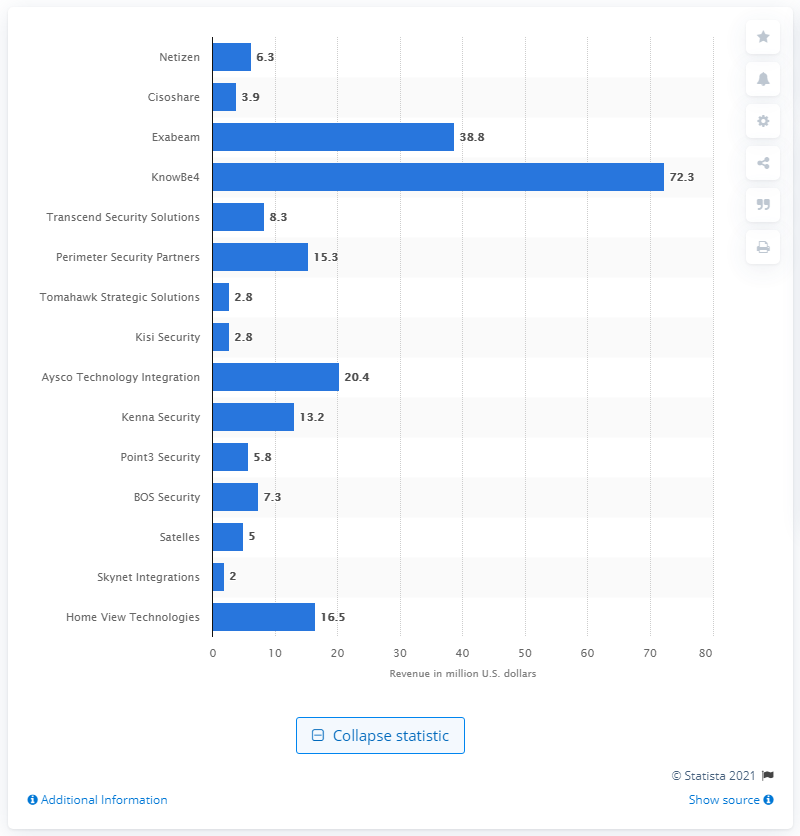Point out several critical features in this image. In 2018, Netizen's revenue was 6.3 million dollars. According to a report, Netizen was the fastest growing security company in the United States in 2018. 